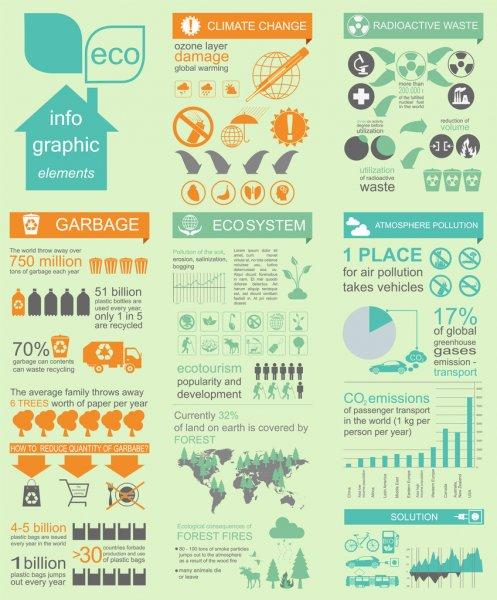Draw attention to some important aspects in this diagram. In the United States, vehicular pollution accounts for approximately 17% of the total atmospheric pollution. 